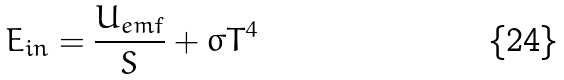<formula> <loc_0><loc_0><loc_500><loc_500>E _ { i n } = \frac { U _ { e m f } } { S } + \sigma T ^ { 4 }</formula> 